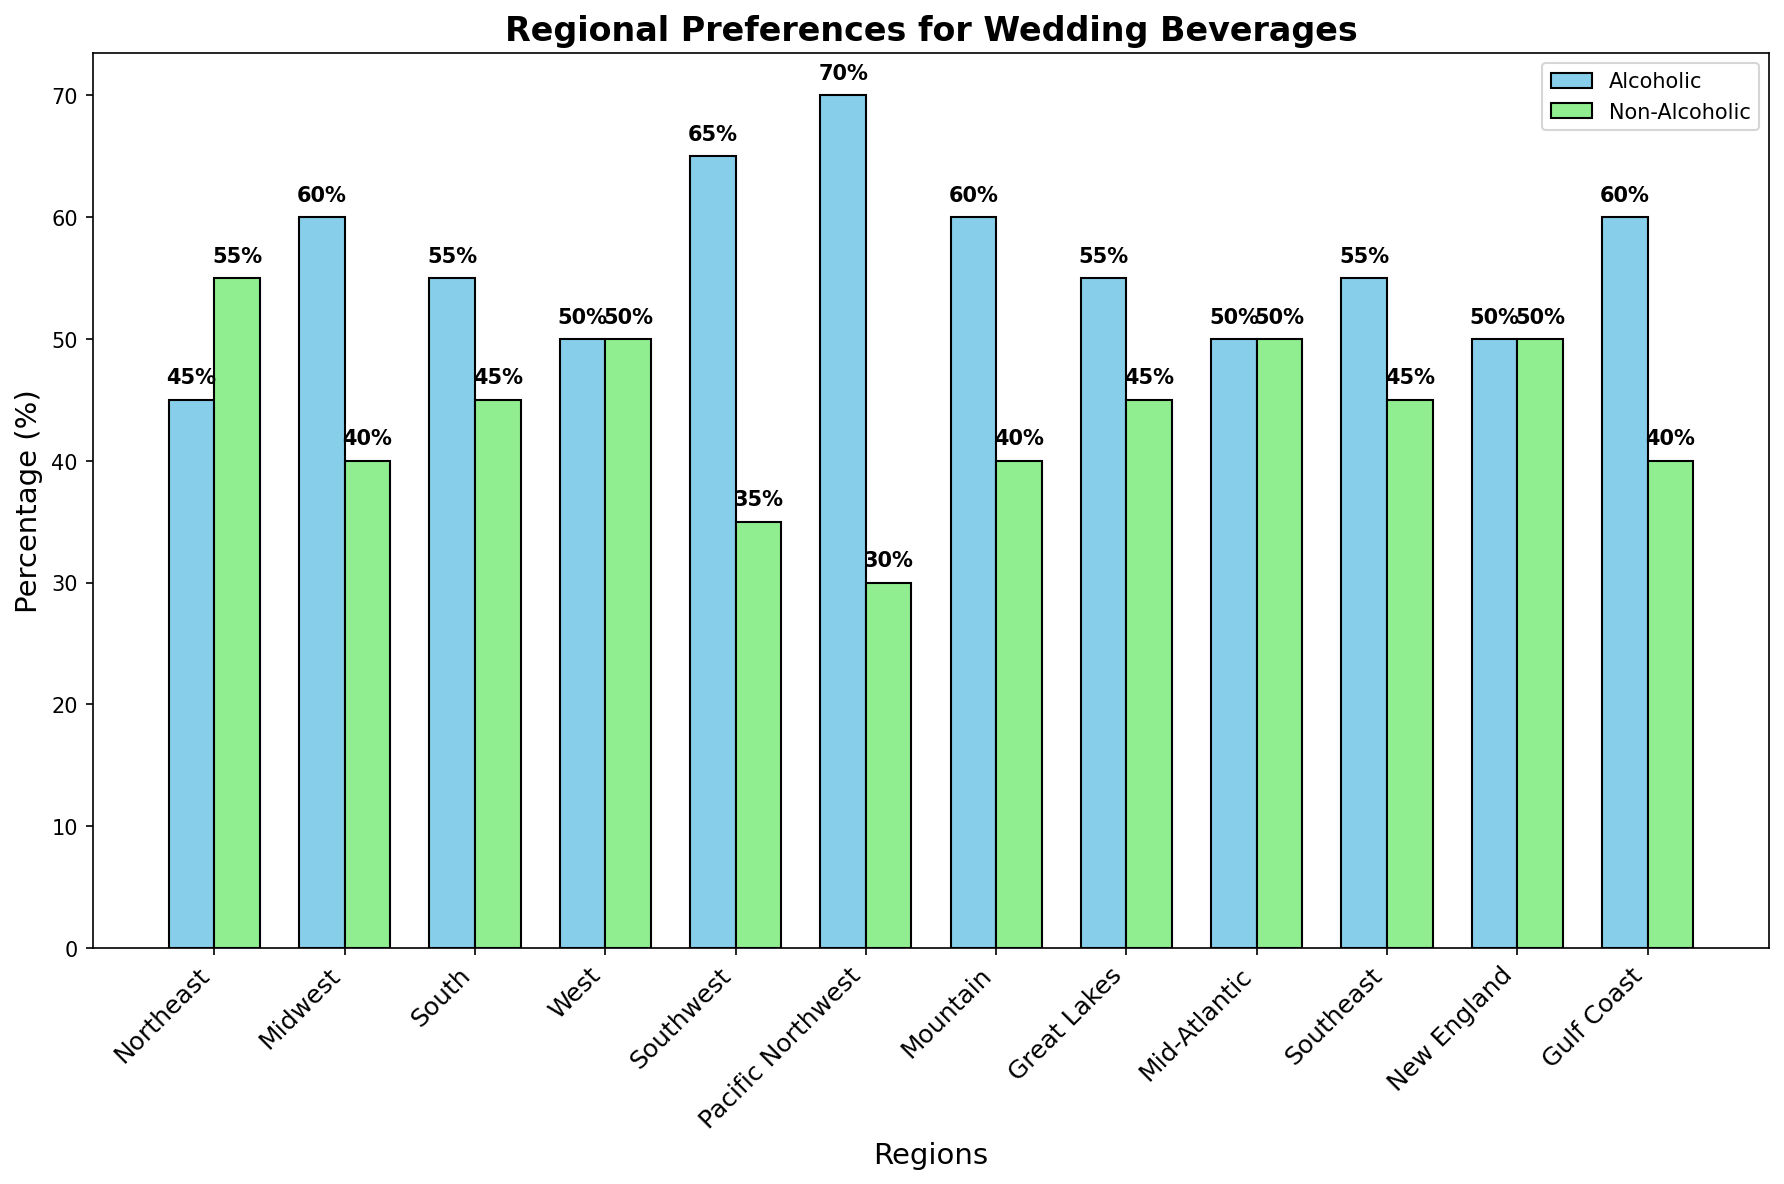Which region has the highest preference for alcoholic beverages? By looking at the heights of the bars, the Pacific Northwest has the tallest bar for alcoholic beverages at 70%.
Answer: Pacific Northwest In which region is there an equal preference for alcoholic and non-alcoholic beverages? By checking where both bars have the same height, there are three regions: West, Mid-Atlantic, and New England, each with 50% preference for both beverage types.
Answer: West, Mid-Atlantic, and New England What is the total percentage of people preferring alcoholic beverages across the Northeast and South regions? Add the percentages of those preferring alcoholic beverages in the Northeast (45%) and the South (55%). 45 + 55 = 100%
Answer: 100% Which region prefers non-alcoholic beverages the most? By identifying the highest bar for non-alcoholic beverages, the Northeast has the tallest bar at 55%.
Answer: Northeast How does the preference for non-alcoholic beverages in the Mountain region compare to the Southeast? Compare the heights of the non-alcoholic bars in the Mountain (40%) and Southeast (45%). 45% is greater than 40%.
Answer: Southeast prefers more What is the average percentage of preference for non-alcoholic beverages across the New England and Great Lakes regions? Add the percentages for non-alcoholic beverages in New England (50%) and Great Lakes (45%), then divide by 2. (50 + 45) / 2 = 47.5%
Answer: 47.5% Which region shows the greatest difference in preference between alcoholic and non-alcoholic beverages? Calculate the differences for each region: Northeast (55-45=10), Midwest (60-40=20), South (55-45=10), West (50-50=0), Southwest (65-35=30), Pacific Northwest (70-30=40), Mountain (60-40=20), Great Lakes (55-45=10), Mid-Atlantic (50-50=0), Southeast (55-45=10), New England (50-50=0), Gulf Coast (60-40=20). The Pacific Northwest has the largest difference.
Answer: Pacific Northwest What's the difference in preference for alcoholic beverages between the Southwest and Gulf Coast regions? Subtract the Southwest percentage (65%) from the Gulf Coast percentage (60%). 65 - 60 = 5%
Answer: 5% Which regions have a preference for non-alcoholic beverages above 40%? Identify regions where the non-alcoholic bar is above 40%: Northeast (55%), South (45%), West (50%), Mid-Atlantic (50%), Southeast (45%), New England (50%).
Answer: Northeast, South, West, Mid-Atlantic, Southeast, New England How many regions have a higher preference for non-alcoholic beverages than alcoholic beverages? Count regions where the non-alcoholic bar is taller: Northeast (55% > 45%). Only one region meets this criterion.
Answer: 1 